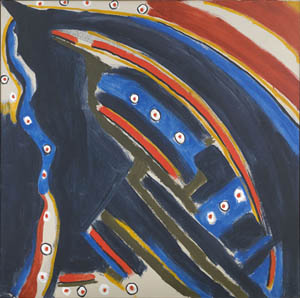How might this painting reflect the artist's inner thoughts or feelings? This painting likely reflects the artist's exploration of their inner world. The chaotic blend of colors could symbolize tumultuous emotions or thoughts, while the dominant abstract shape suggests an attempt to find structure or meaning amidst the chaos. The use of bright dots scattered throughout the dark background might indicate moments of clarity or inspiration that arise in the midst of inner turmoil. Overall, the painting seems to be a visual diary, capturing the artist's emotional journey and inner struggles. Can you describe a realistic scenario that this image might depict if interpreted literally? Literally interpreted, the painting could depict an aerial view of a futuristic cityscape at night. The central abstract shape might represent a spacecraft or futuristic building with lights (dots) illuminating the city. The mix of blue and black gives a night-time feel, while the white outline provides a sense of structure and dimension to the futuristic architecture. Please describe an imaginative and detailed story inspired by this artwork. In a distant galaxy, there exists a celestial haven known as Arcadia. This sanctuary is home to beings of light who protect and nurture the stars. One being, named Lumina, is tasked with safeguarding the constellations from dark entities that seek to snuff out the light. The painting captures the essence of Lumina's epic journey through the cosmos. Her form, an ethereal blend of blue and black, glows with radiant energy. The scattered dots are not merely stars but represent the souls of ancient guardians who guide and assist her on her quest. The white outline represents the protective barrier she weaves around each constellation, ensuring their eternal glow. The swirling colors are trails left by her swift movements, a testament to her perpetual vigilance. In this vivid world, Lumina's story is one of bravery, resilience, and the unending battle to preserve the light in the darkest corners of the universe. 